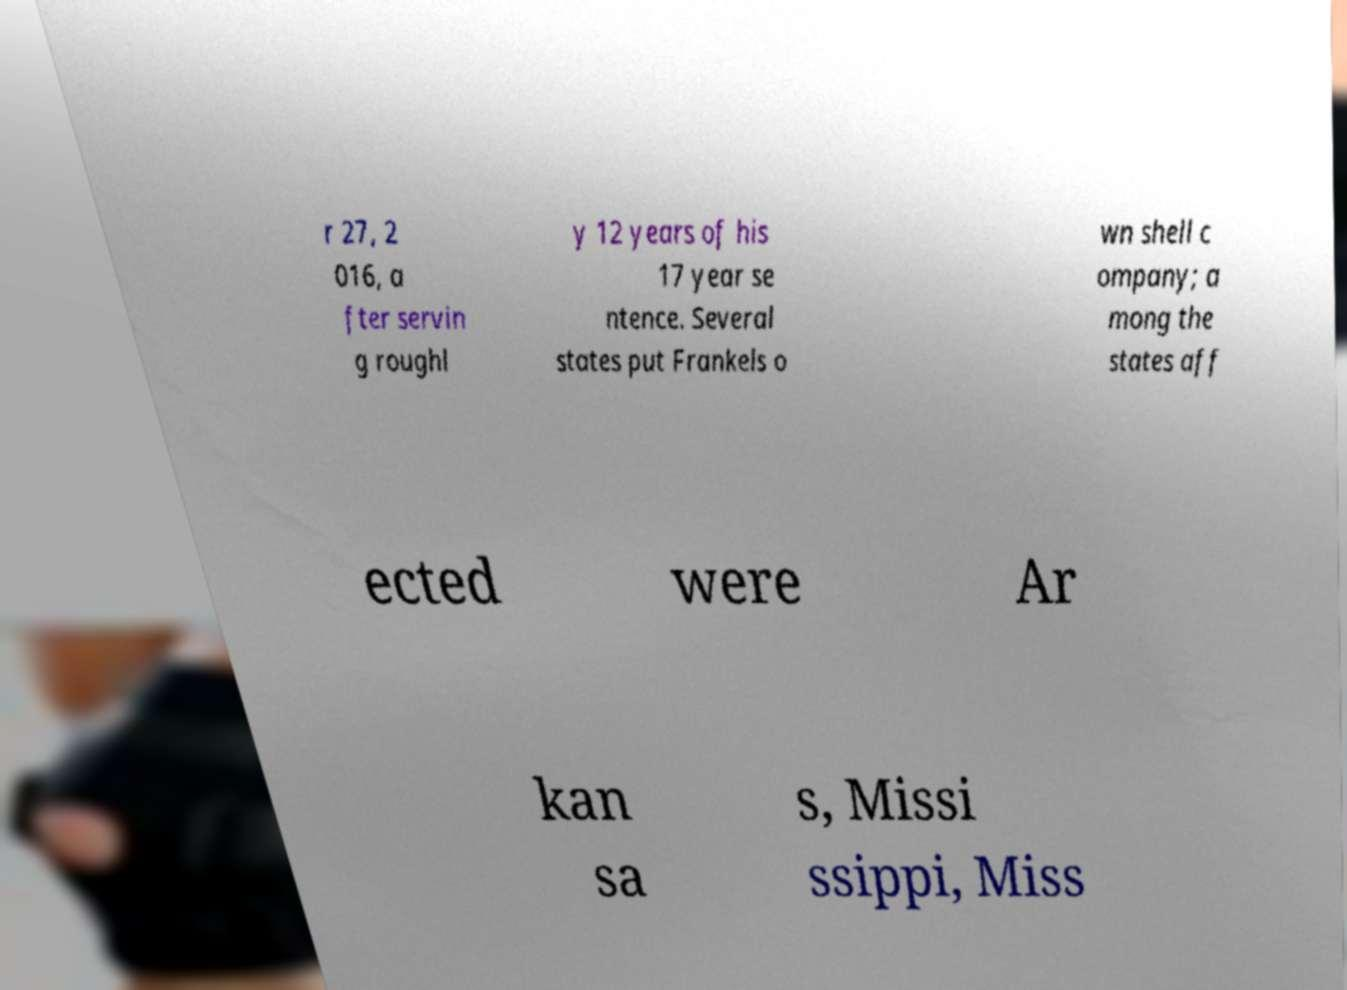For documentation purposes, I need the text within this image transcribed. Could you provide that? r 27, 2 016, a fter servin g roughl y 12 years of his 17 year se ntence. Several states put Frankels o wn shell c ompany; a mong the states aff ected were Ar kan sa s, Missi ssippi, Miss 